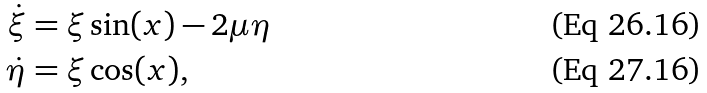<formula> <loc_0><loc_0><loc_500><loc_500>\dot { \xi } & = \xi \sin ( x ) - 2 \mu \eta \\ \dot { \eta } & = \xi \cos ( x ) ,</formula> 